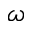<formula> <loc_0><loc_0><loc_500><loc_500>\omega</formula> 